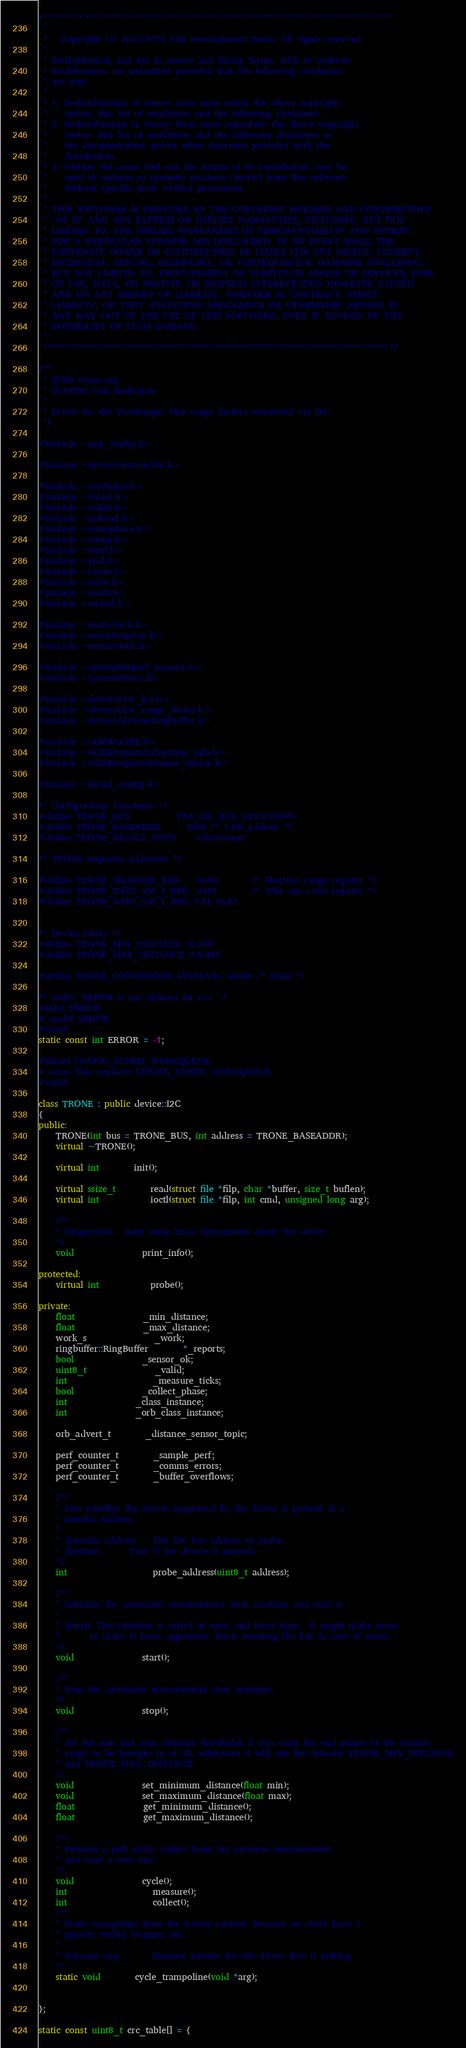Convert code to text. <code><loc_0><loc_0><loc_500><loc_500><_C++_>/****************************************************************************
 *
 *   Copyright (c) 2013-2015 PX4 Development Team. All rights reserved.
 *
 * Redistribution and use in source and binary forms, with or without
 * modification, are permitted provided that the following conditions
 * are met:
 *
 * 1. Redistributions of source code must retain the above copyright
 *    notice, this list of conditions and the following disclaimer.
 * 2. Redistributions in binary form must reproduce the above copyright
 *    notice, this list of conditions and the following disclaimer in
 *    the documentation and/or other materials provided with the
 *    distribution.
 * 3. Neither the name PX4 nor the names of its contributors may be
 *    used to endorse or promote products derived from this software
 *    without specific prior written permission.
 *
 * THIS SOFTWARE IS PROVIDED BY THE COPYRIGHT HOLDERS AND CONTRIBUTORS
 * "AS IS" AND ANY EXPRESS OR IMPLIED WARRANTIES, INCLUDING, BUT NOT
 * LIMITED TO, THE IMPLIED WARRANTIES OF MERCHANTABILITY AND FITNESS
 * FOR A PARTICULAR PURPOSE ARE DISCLAIMED. IN NO EVENT SHALL THE
 * COPYRIGHT OWNER OR CONTRIBUTORS BE LIABLE FOR ANY DIRECT, INDIRECT,
 * INCIDENTAL, SPECIAL, EXEMPLARY, OR CONSEQUENTIAL DAMAGES (INCLUDING,
 * BUT NOT LIMITED TO, PROCUREMENT OF SUBSTITUTE GOODS OR SERVICES; LOSS
 * OF USE, DATA, OR PROFITS; OR BUSINESS INTERRUPTION) HOWEVER CAUSED
 * AND ON ANY THEORY OF LIABILITY, WHETHER IN CONTRACT, STRICT
 * LIABILITY, OR TORT (INCLUDING NEGLIGENCE OR OTHERWISE) ARISING IN
 * ANY WAY OUT OF THE USE OF THIS SOFTWARE, EVEN IF ADVISED OF THE
 * POSSIBILITY OF SUCH DAMAGE.
 *
 ****************************************************************************/

/**
 * @file trone.cpp
 * @author Luis Rodrigues
 *
 * Driver for the TeraRanger One range finders connected via I2C.
 */

#include <px4_config.h>

#include <drivers/device/i2c.h>

#include <sys/types.h>
#include <stdint.h>
#include <stdlib.h>
#include <stdbool.h>
#include <semaphore.h>
#include <string.h>
#include <fcntl.h>
#include <poll.h>
#include <errno.h>
#include <stdio.h>
#include <math.h>
#include <unistd.h>

#include <nuttx/arch.h>
#include <nuttx/wqueue.h>
#include <nuttx/clock.h>

#include <systemlib/perf_counter.h>
#include <systemlib/err.h>

#include <drivers/drv_hrt.h>
#include <drivers/drv_range_finder.h>
#include <drivers/device/ringbuffer.h>

#include <uORB/uORB.h>
#include <uORB/topics/subsystem_info.h>
#include <uORB/topics/distance_sensor.h>

#include <board_config.h>

/* Configuration Constants */
#define TRONE_BUS           PX4_I2C_BUS_EXPANSION
#define TRONE_BASEADDR      0x30 /* 7-bit address */
#define TRONE_DEVICE_PATH   	"/dev/trone"

/* TRONE Registers addresses */

#define TRONE_MEASURE_REG	0x00		/* Measure range register */
#define TRONE_WHO_AM_I_REG  0x01        /* Who am I test register */
#define TRONE_WHO_AM_I_REG_VAL 0xA1


/* Device limits */
#define TRONE_MIN_DISTANCE (0.20f)
#define TRONE_MAX_DISTANCE (14.00f)

#define TRONE_CONVERSION_INTERVAL 50000 /* 50ms */

/* oddly, ERROR is not defined for c++ */
#ifdef ERROR
# undef ERROR
#endif
static const int ERROR = -1;

#ifndef CONFIG_SCHED_WORKQUEUE
# error This requires CONFIG_SCHED_WORKQUEUE.
#endif

class TRONE : public device::I2C
{
public:
	TRONE(int bus = TRONE_BUS, int address = TRONE_BASEADDR);
	virtual ~TRONE();

	virtual int 		init();

	virtual ssize_t		read(struct file *filp, char *buffer, size_t buflen);
	virtual int			ioctl(struct file *filp, int cmd, unsigned long arg);

	/**
	* Diagnostics - print some basic information about the driver.
	*/
	void				print_info();

protected:
	virtual int			probe();

private:
	float				_min_distance;
	float				_max_distance;
	work_s				_work;
	ringbuffer::RingBuffer		*_reports;
	bool				_sensor_ok;
	uint8_t				_valid;
	int					_measure_ticks;
	bool				_collect_phase;
	int				_class_instance;
	int				_orb_class_instance;

	orb_advert_t		_distance_sensor_topic;

	perf_counter_t		_sample_perf;
	perf_counter_t		_comms_errors;
	perf_counter_t		_buffer_overflows;

	/**
	* Test whether the device supported by the driver is present at a
	* specific address.
	*
	* @param address	The I2C bus address to probe.
	* @return		True if the device is present.
	*/
	int					probe_address(uint8_t address);

	/**
	* Initialise the automatic measurement state machine and start it.
	*
	* @note This function is called at open and error time.  It might make sense
	*       to make it more aggressive about resetting the bus in case of errors.
	*/
	void				start();

	/**
	* Stop the automatic measurement state machine.
	*/
	void				stop();

	/**
	* Set the min and max distance thresholds if you want the end points of the sensors
	* range to be brought in at all, otherwise it will use the defaults TRONE_MIN_DISTANCE
	* and TRONE_MAX_DISTANCE
	*/
	void				set_minimum_distance(float min);
	void				set_maximum_distance(float max);
	float				get_minimum_distance();
	float				get_maximum_distance();

	/**
	* Perform a poll cycle; collect from the previous measurement
	* and start a new one.
	*/
	void				cycle();
	int					measure();
	int					collect();
	/**
	* Static trampoline from the workq context; because we don't have a
	* generic workq wrapper yet.
	*
	* @param arg		Instance pointer for the driver that is polling.
	*/
	static void		cycle_trampoline(void *arg);


};

static const uint8_t crc_table[] = {</code> 